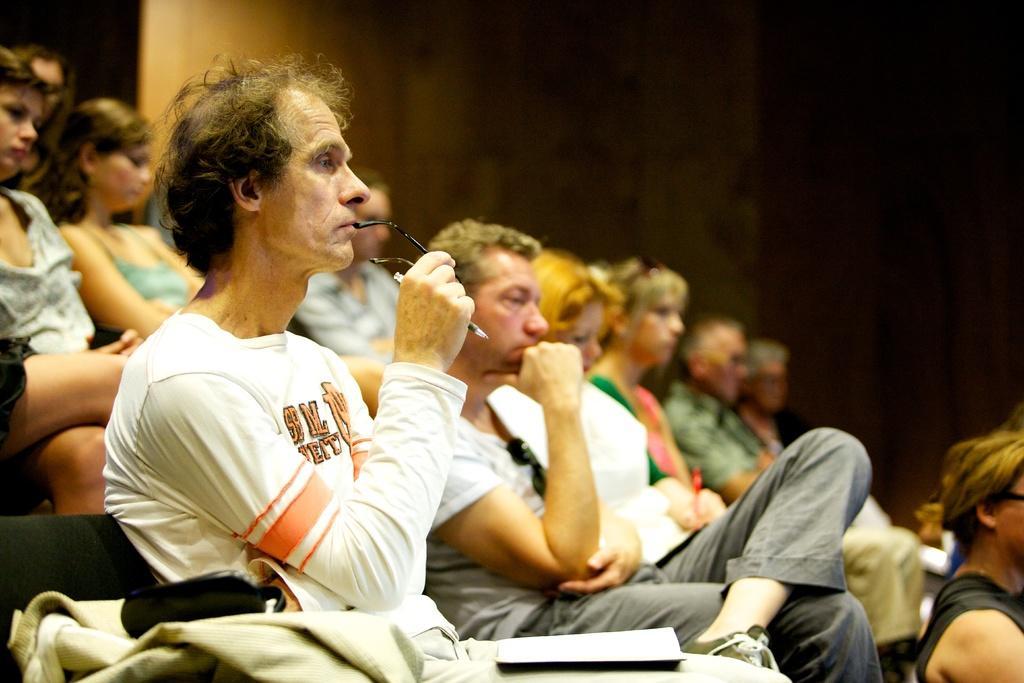Describe this image in one or two sentences. In this image we can see people sitting. At the bottom there is a book and a cloth. In the background there is a wall. 